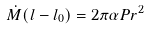<formula> <loc_0><loc_0><loc_500><loc_500>\dot { M } ( l - l _ { 0 } ) = 2 \pi \alpha P r ^ { 2 }</formula> 